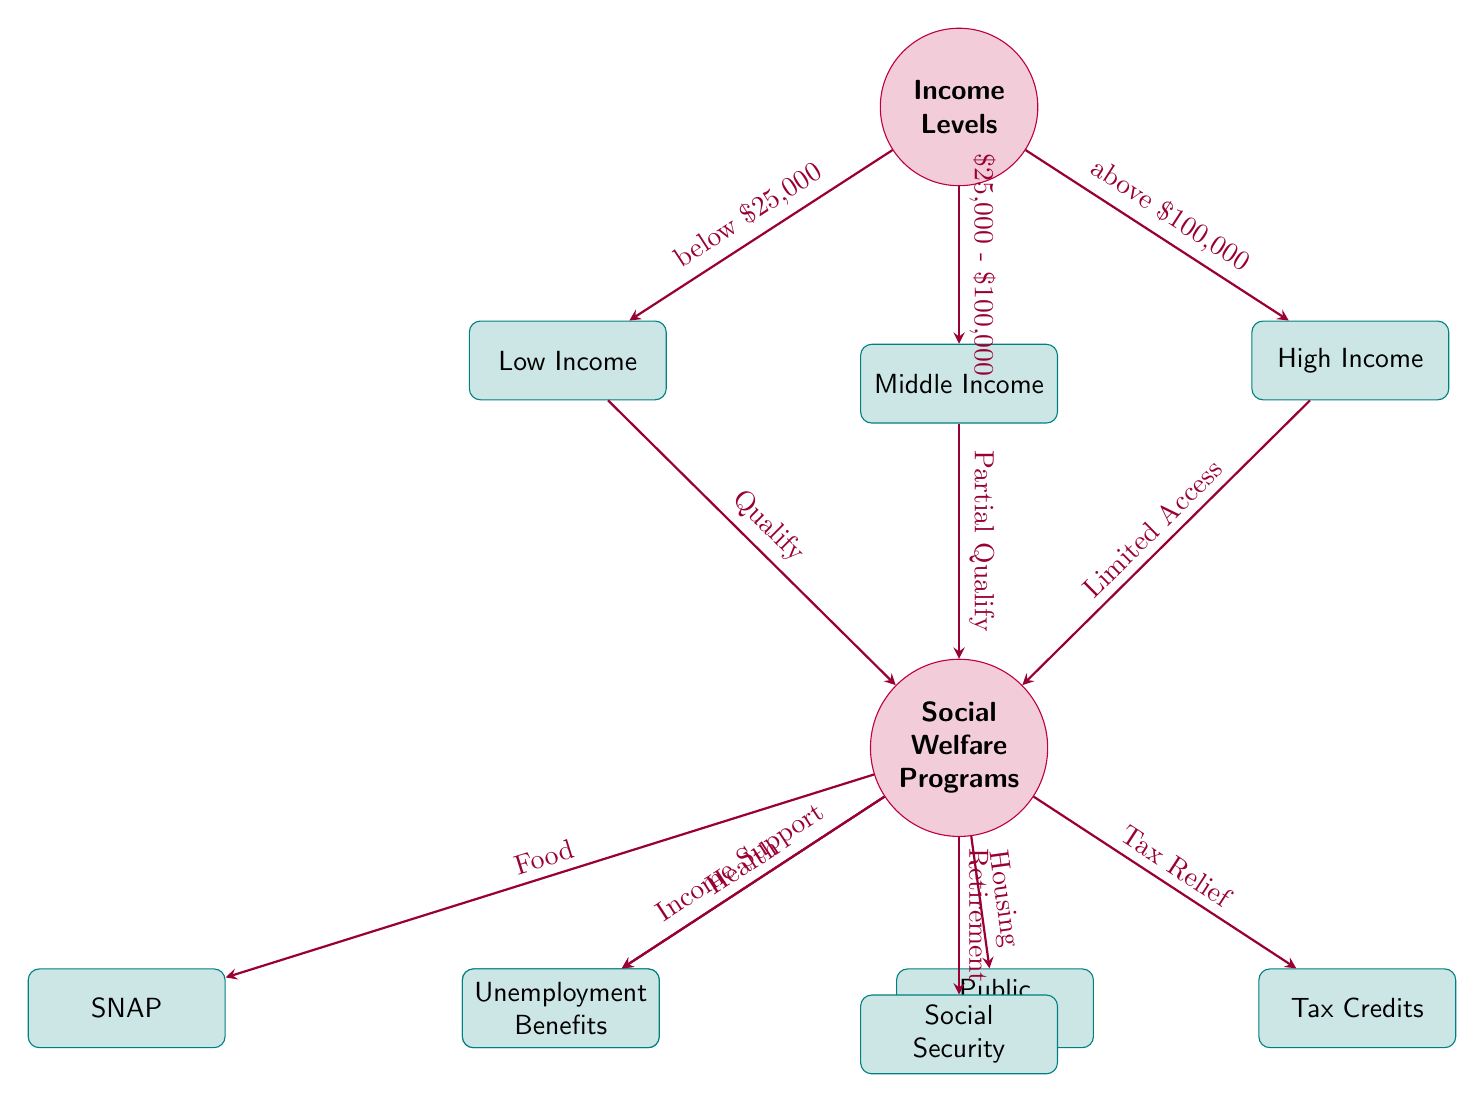What income level corresponds to Medicaid access? According to the diagram, Medicaid is accessed by individuals in the Low Income category, which is defined as having an income below $25,000.
Answer: Low Income How many social welfare programs are shown in the diagram? The diagram lists six social welfare programs: Medicaid, SNAP, Public Housing, Unemployment Benefits, Social Security, and Tax Credits. Counting these gives a total of six.
Answer: 6 What is the income range for partial qualification of social welfare programs? The diagram indicates that the income range for partial qualification is between $25,000 and $100,000, as denoted by the arrow linking the Middle Income node to the Social Welfare Programs node.
Answer: $25,000 - $100,000 Which social welfare program is linked to income support? The diagram shows that Unemployment Benefits are designated as the program linked to income support from the Social Welfare Programs node.
Answer: Unemployment Benefits What is the access level of high-income individuals to social welfare programs? The diagram states that individuals in the High Income category have limited access to social welfare programs, as indicated by the arrow from the High Income node to the Social Welfare Programs node.
Answer: Limited Access Which program provides tax relief? The diagram explicitly identifies Tax Credits as the program associated with tax relief, illustrated by the arrow coming from the Social Welfare Programs node to the Tax Credits node.
Answer: Tax Credits What is the main connection type between income levels and social welfare programs? The main connection type illustrated in the diagram between income levels and social welfare programs is through a qualification process, with arrows indicating access and qualifying conditions based on income level.
Answer: Qualification Which income level corresponds to Public Housing? The diagram links Public Housing to the welfare programs accessible for Low Income individuals, making it clear that this program is associated with that income group.
Answer: Low Income 